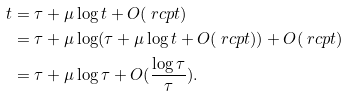Convert formula to latex. <formula><loc_0><loc_0><loc_500><loc_500>t & = \tau + \mu \log t + O ( \ r c p t ) \\ & = \tau + \mu \log ( \tau + \mu \log t + O ( \ r c p t ) ) + O ( \ r c p t ) \\ & = \tau + \mu \log \tau + O ( \frac { \log \tau } { \tau } ) .</formula> 